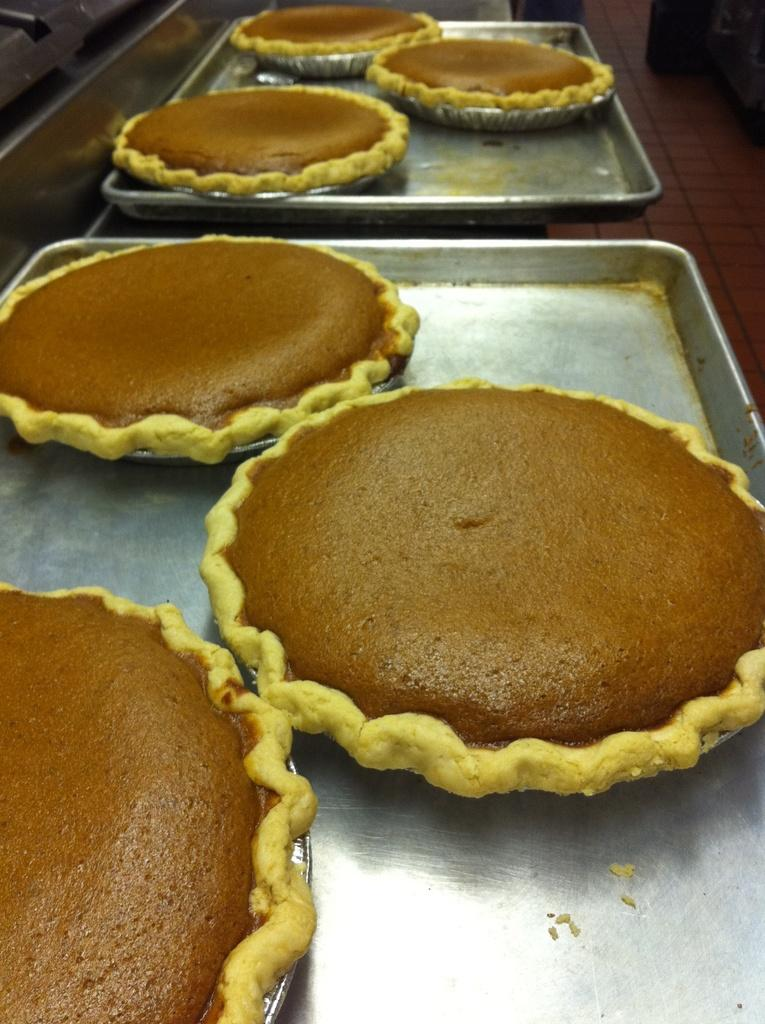What type of objects are present in the image? There are food items in the image. How are the food items arranged or organized? The food items are in trays. What colors can be observed in the food items? The food items have brown and yellow colors. What type of slope can be seen in the image? There is no slope present in the image; it features food items in trays with brown and yellow colors. 